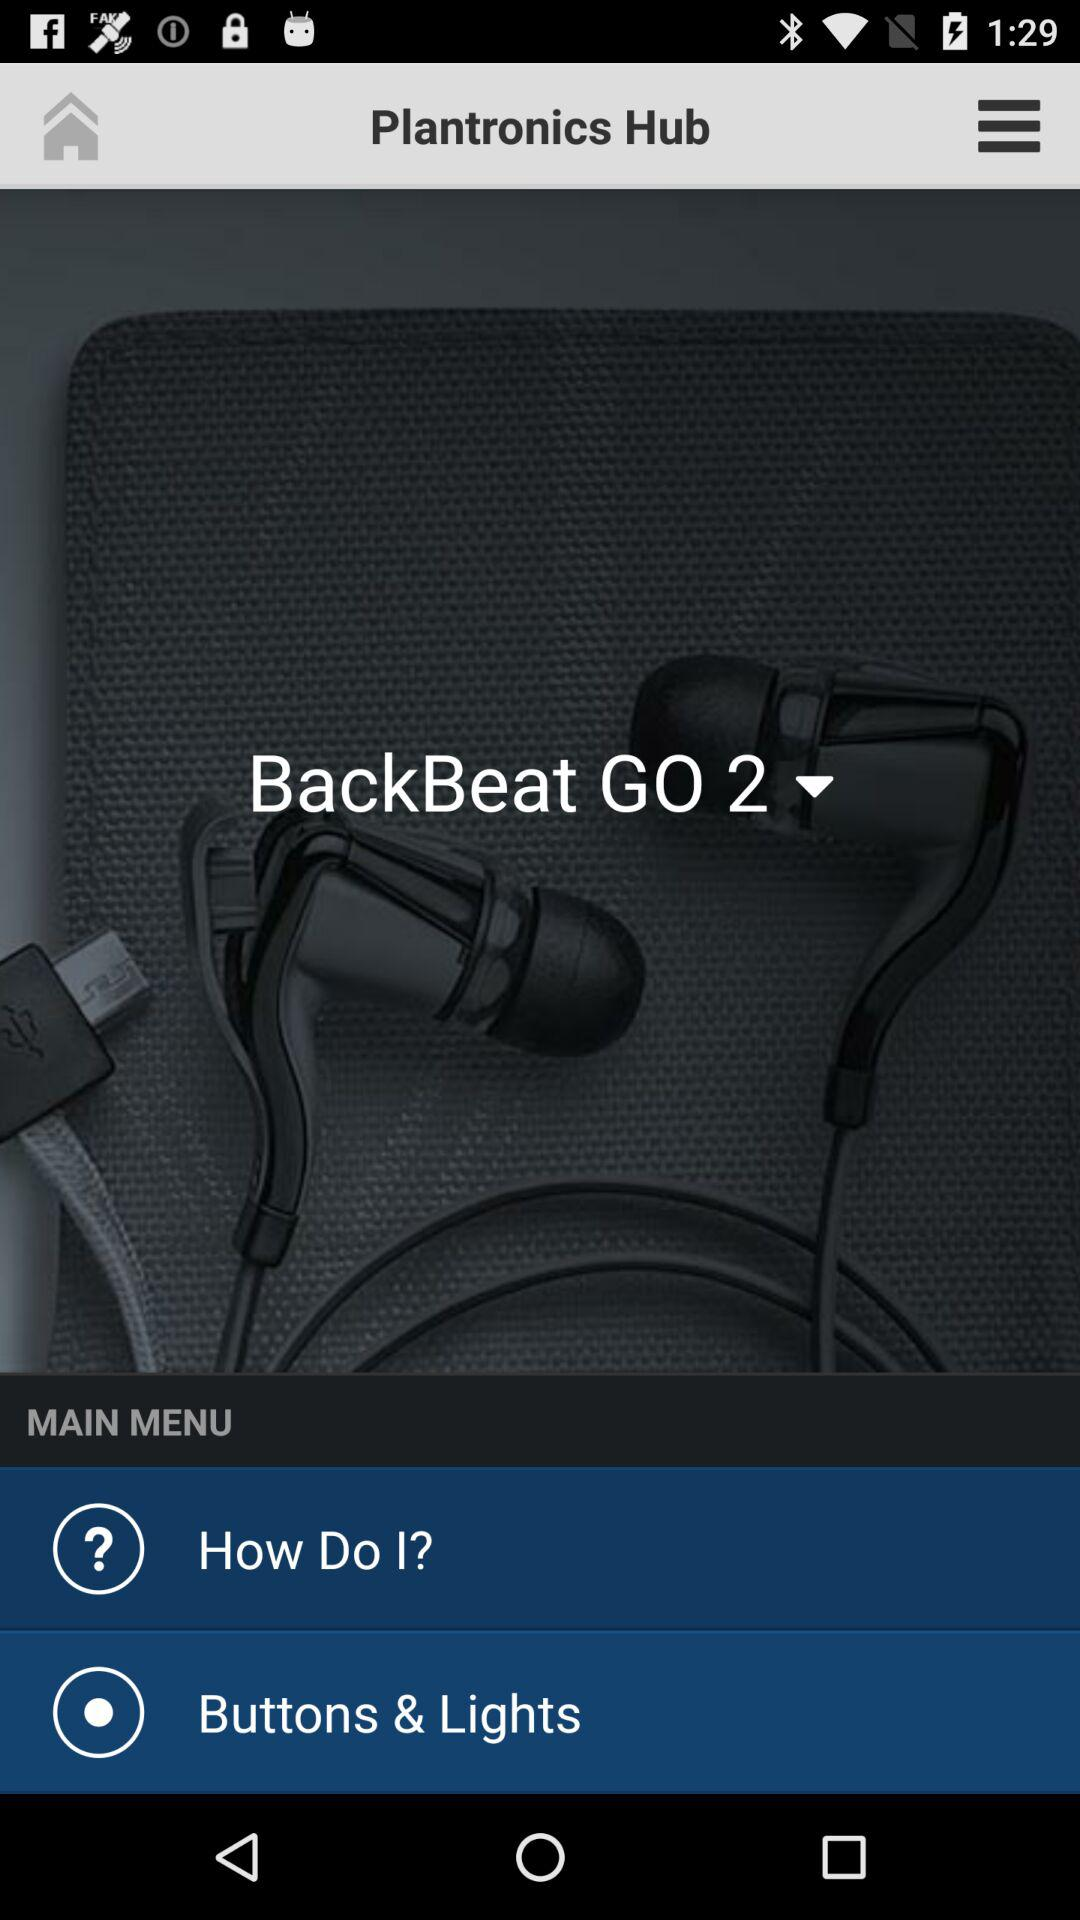What is the name of the application? The name of the application is "Plantronics Hub". 